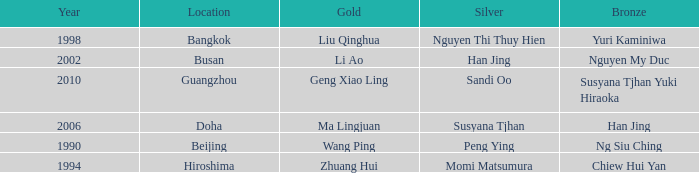What's the lowest Year with the Location of Bangkok? 1998.0. 